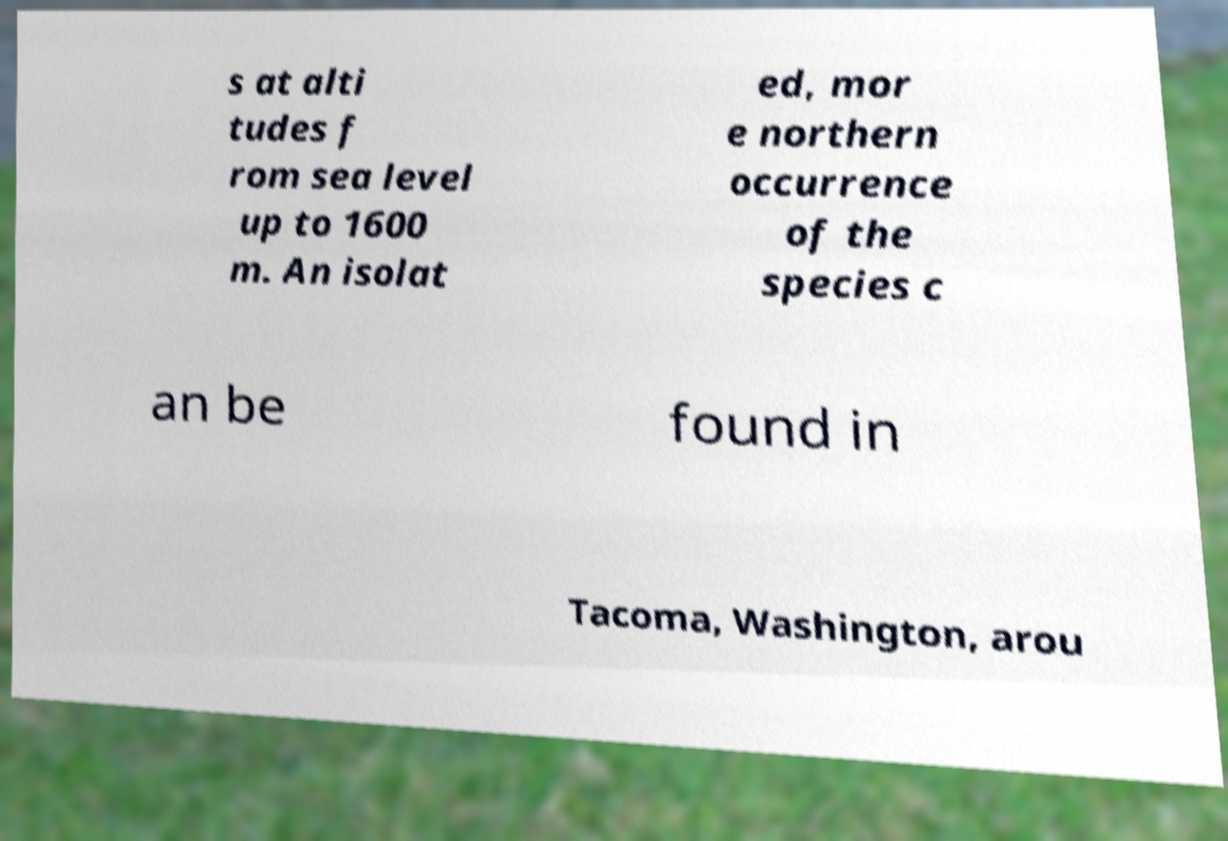Please read and relay the text visible in this image. What does it say? s at alti tudes f rom sea level up to 1600 m. An isolat ed, mor e northern occurrence of the species c an be found in Tacoma, Washington, arou 